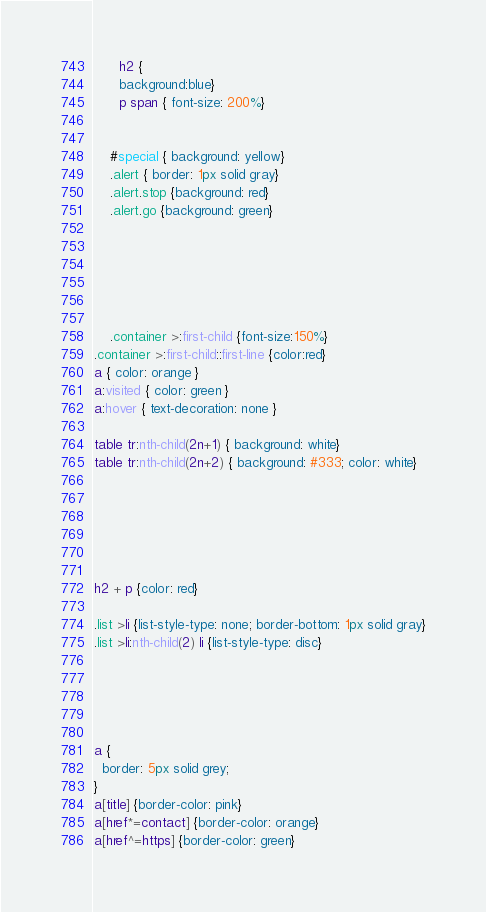Convert code to text. <code><loc_0><loc_0><loc_500><loc_500><_CSS_>      h2 {
      background:blue}
      p span { font-size: 200%}

      
    #special { background: yellow}
    .alert { border: 1px solid gray}
    .alert.stop {background: red}
    .alert.go {background: green}





    
    .container >:first-child {font-size:150%}
.container >:first-child::first-line {color:red}
a { color: orange }
a:visited { color: green } 
a:hover { text-decoration: none }

table tr:nth-child(2n+1) { background: white}
table tr:nth-child(2n+2) { background: #333; color: white}






h2 + p {color: red}

.list >li {list-style-type: none; border-bottom: 1px solid gray}
.list >li:nth-child(2) li {list-style-type: disc}





a {
  border: 5px solid grey;
}
a[title] {border-color: pink}
a[href*=contact] {border-color: orange}
a[href^=https] {border-color: green}</code> 